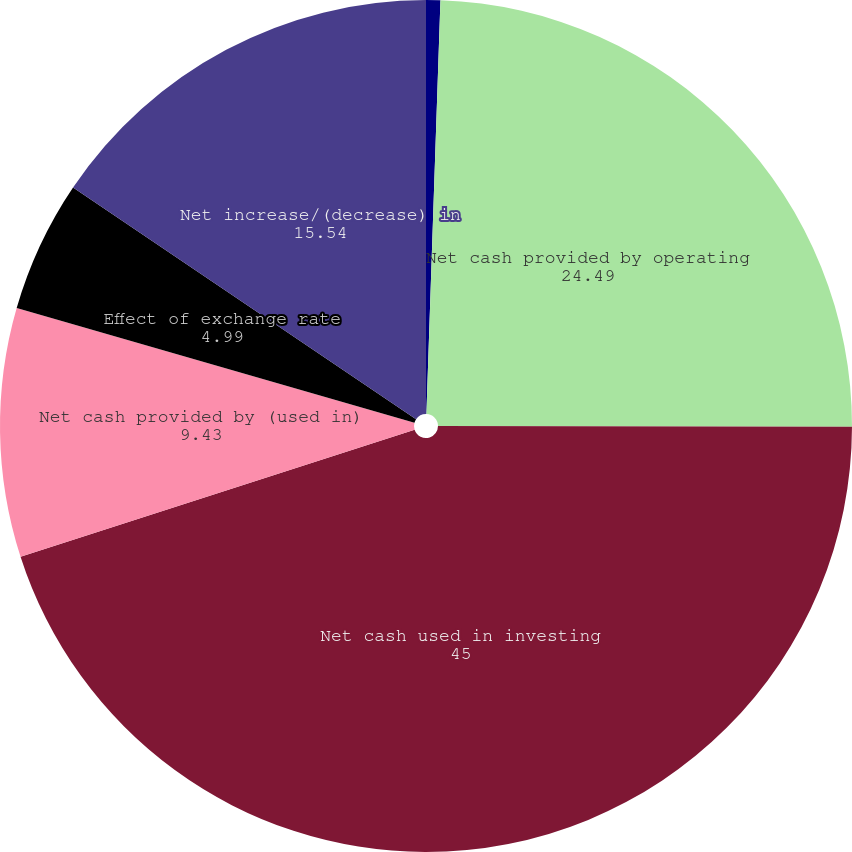Convert chart. <chart><loc_0><loc_0><loc_500><loc_500><pie_chart><fcel>(in thousands)<fcel>Net cash provided by operating<fcel>Net cash used in investing<fcel>Net cash provided by (used in)<fcel>Effect of exchange rate<fcel>Net increase/(decrease) in<nl><fcel>0.54%<fcel>24.49%<fcel>45.0%<fcel>9.43%<fcel>4.99%<fcel>15.54%<nl></chart> 